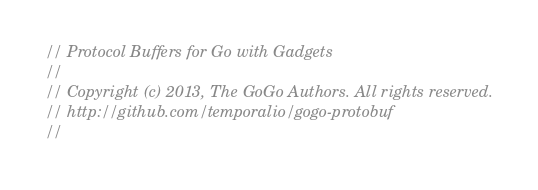<code> <loc_0><loc_0><loc_500><loc_500><_Go_>// Protocol Buffers for Go with Gadgets
//
// Copyright (c) 2013, The GoGo Authors. All rights reserved.
// http://github.com/temporalio/gogo-protobuf
//</code> 